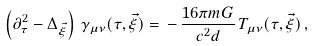Convert formula to latex. <formula><loc_0><loc_0><loc_500><loc_500>\left ( \partial ^ { 2 } _ { \tau } - \Delta _ { \vec { \xi } } \right ) \, \gamma _ { \mu \nu } ( \tau , \vec { \xi } ) = \, - \, \frac { 1 6 \pi m G } { c ^ { 2 } d } \, T _ { \mu \nu } ( \tau , \vec { \xi } ) \, ,</formula> 